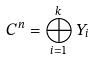<formula> <loc_0><loc_0><loc_500><loc_500>C ^ { n } = \bigoplus _ { i = 1 } ^ { k } Y _ { i }</formula> 